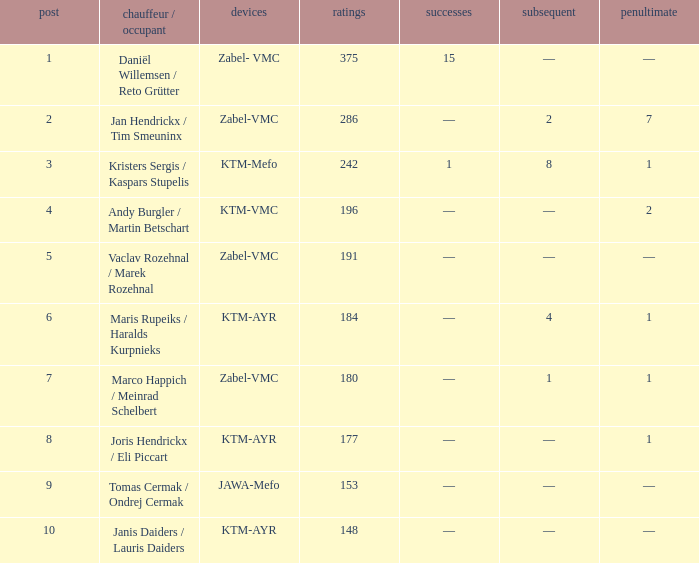Who was the driver/passengar when the position was smaller than 8, the third was 1, and there was 1 win? Kristers Sergis / Kaspars Stupelis. 